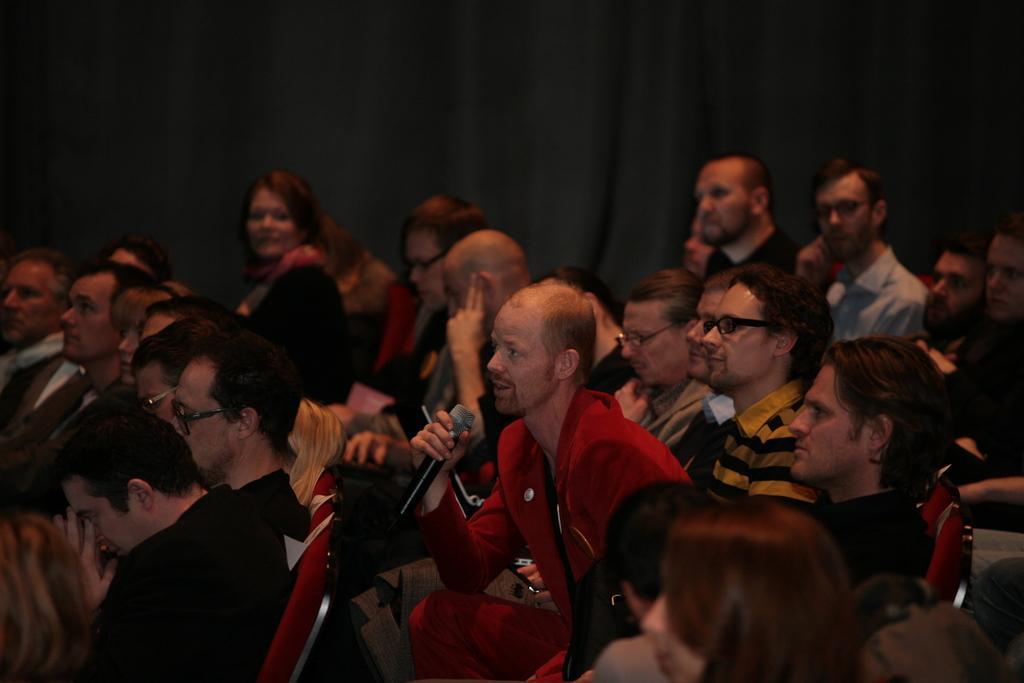In one or two sentences, can you explain what this image depicts? Persons are sitting on red chairs. Few persons wore spectacles. The man wore red shirt and holding mic. 